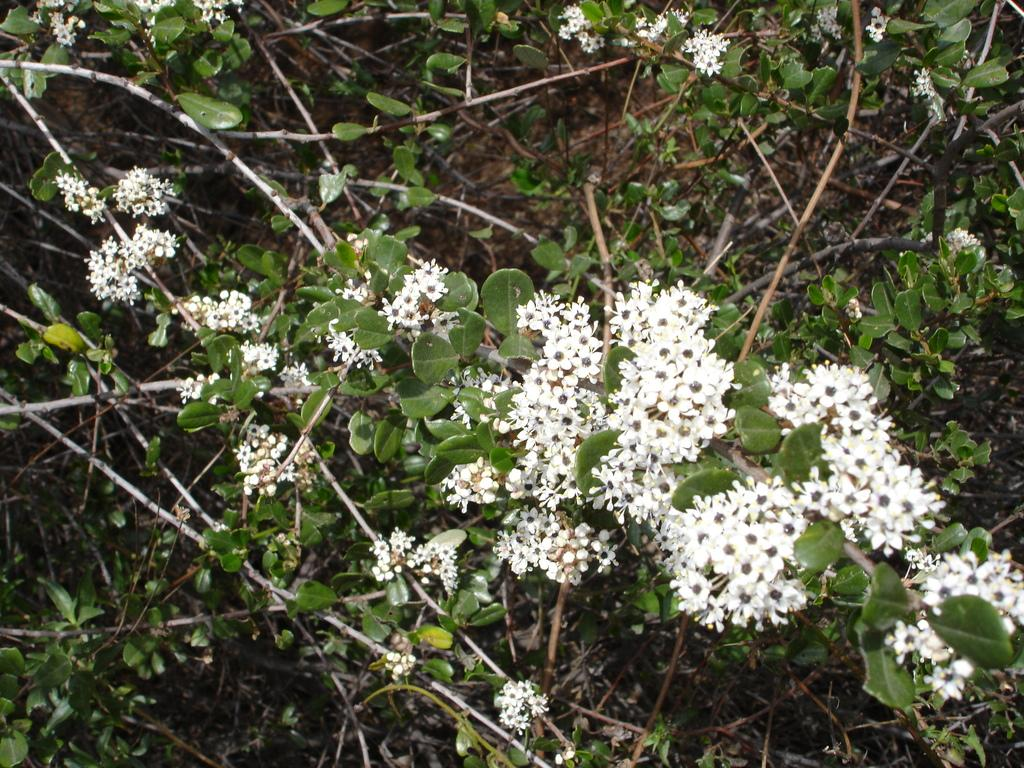Where was the image taken? The image was taken outdoors. What can be seen in the image besides the outdoor setting? There are plants in the image. What are the characteristics of the plants' leaves? The plants have green leaves. What is the color of the flowers on the plants? The flowers on the plants are white in color. Where is the faucet located in the image? There is no faucet present in the image. Can you describe the zephyr blowing through the plants in the image? There is no mention of a zephyr or any wind in the image; it simply shows plants with green leaves and white flowers. 